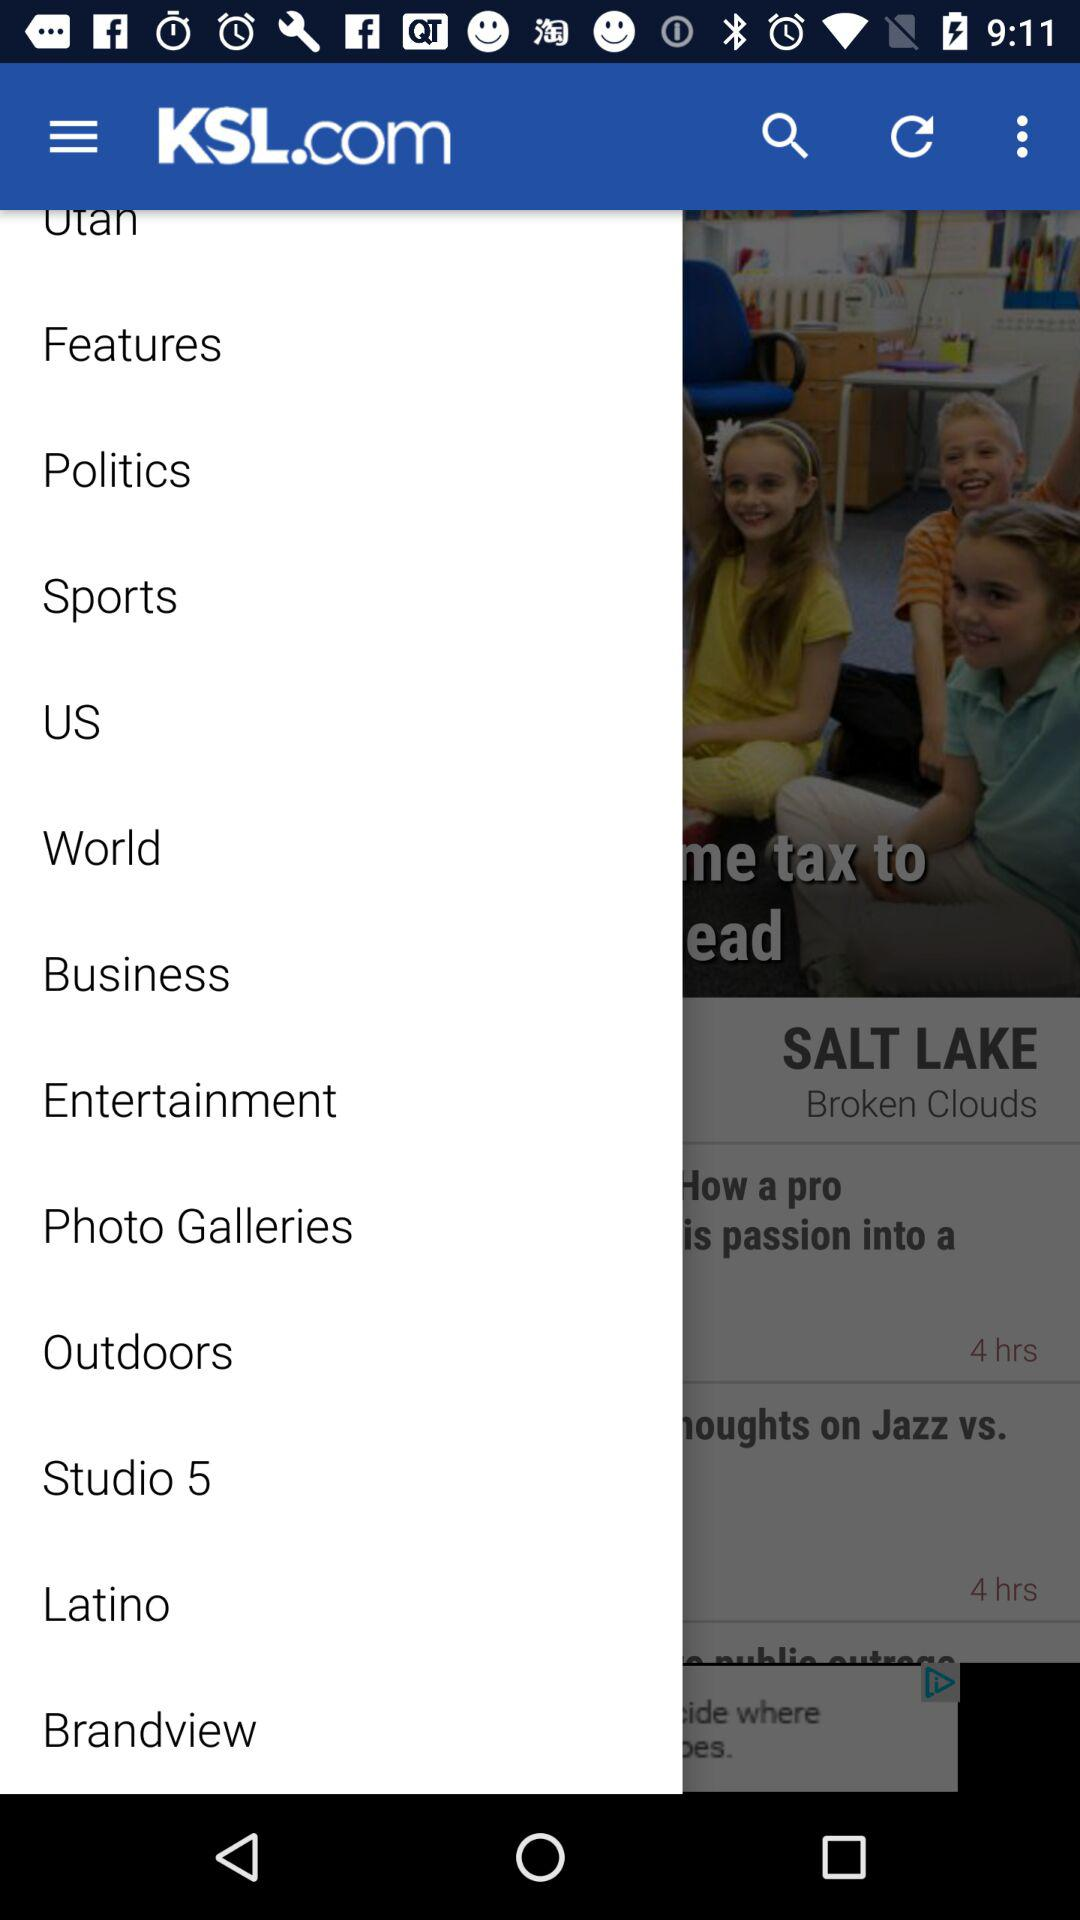What is the application name? The application name is "KSL.com". 